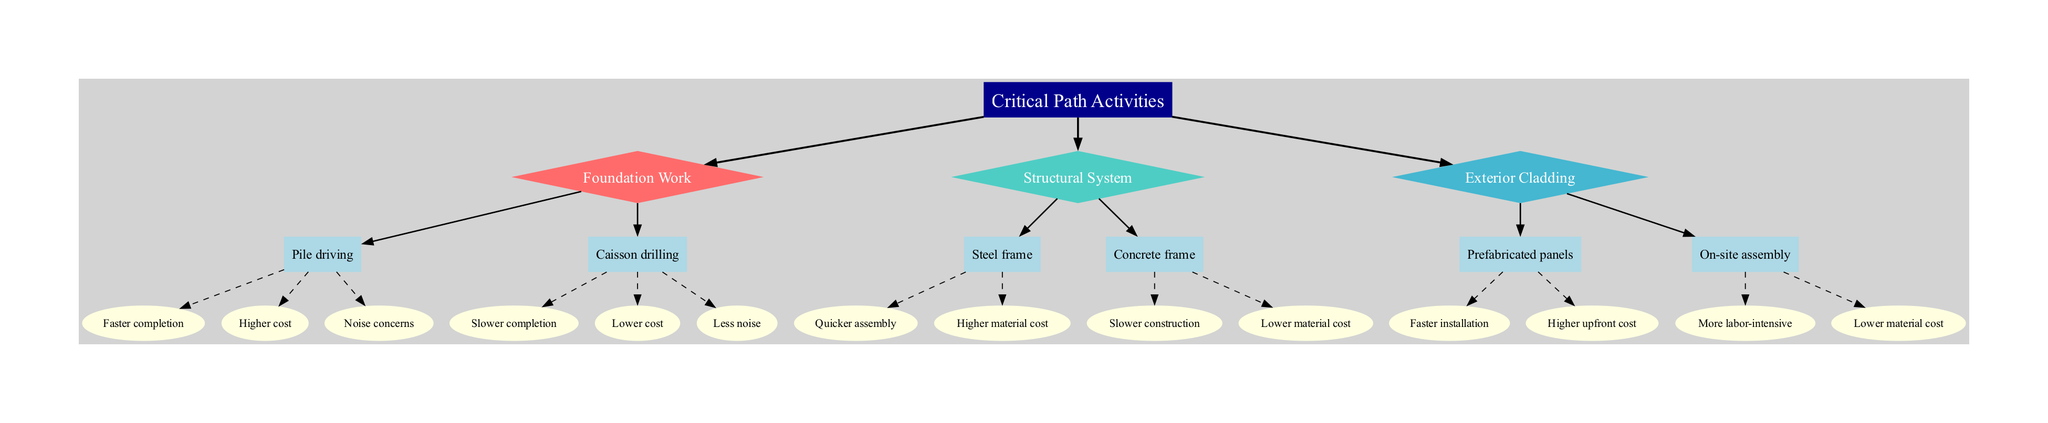What is the root node of the decision tree? The root node is labeled "Critical Path Activities," which is the starting point of the decision tree and indicates the main focus of the decisions that follow.
Answer: Critical Path Activities How many decision nodes are present in the diagram? There are three decision nodes: "Foundation Work," "Structural System," and "Exterior Cladding." Each of these nodes represents a critical area of decision-making in the construction phase.
Answer: 3 Which choice leads to quicker assembly in the Structural System? The choice that leads to quicker assembly is "Steel frame." This option is specified under the "Structural System" decision node.
Answer: Steel frame What is a consequence of choosing "On-site assembly" for Exterior Cladding? One consequence of choosing "On-site assembly" is that it is "More labor-intensive," implying that it requires more manual work compared to prefabricated options.
Answer: More labor-intensive What two consequences does "Pile driving" have? The two consequences of choosing "Pile driving" are "Faster completion" and "Higher cost." These consequences indicate the benefits and drawbacks of this choice in foundation work.
Answer: Faster completion, Higher cost Which option in the Foundation Work leads to lower noise? The option that leads to lower noise is "Caisson drilling." This choice specifies its advantage in terms of noise levels compared to pile driving.
Answer: Caisson drilling What is the material cost comparison between Steel frame and Concrete frame? "Steel frame" has a higher material cost than "Concrete frame." The diagram explicitly compares these two options under the Structural System decision node.
Answer: Higher material cost If the decision is made to use prefabricated panels, what is one consequence? One consequence of using prefabricated panels is a "Higher upfront cost." This indicates that although the installation may be faster, it comes with a higher initial financial requirement.
Answer: Higher upfront cost What links the root to the decision nodes? The links from the root to the decision nodes are the edges that represent decisions made in the construction phase. These edges connect the central focus of the project with specific areas of concern in the diagram.
Answer: Edges 